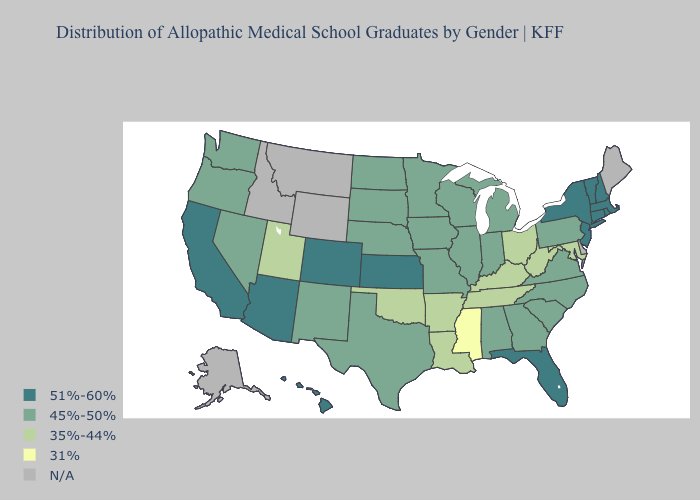Name the states that have a value in the range 51%-60%?
Short answer required. Arizona, California, Colorado, Connecticut, Florida, Hawaii, Kansas, Massachusetts, New Hampshire, New Jersey, New York, Rhode Island, Vermont. What is the highest value in the USA?
Answer briefly. 51%-60%. What is the lowest value in the USA?
Write a very short answer. 31%. Does Massachusetts have the lowest value in the USA?
Concise answer only. No. What is the highest value in the USA?
Short answer required. 51%-60%. Name the states that have a value in the range 35%-44%?
Give a very brief answer. Arkansas, Kentucky, Louisiana, Maryland, Ohio, Oklahoma, Tennessee, Utah, West Virginia. Which states have the lowest value in the South?
Keep it brief. Mississippi. Is the legend a continuous bar?
Be succinct. No. What is the highest value in the West ?
Be succinct. 51%-60%. Name the states that have a value in the range 35%-44%?
Short answer required. Arkansas, Kentucky, Louisiana, Maryland, Ohio, Oklahoma, Tennessee, Utah, West Virginia. What is the value of Hawaii?
Give a very brief answer. 51%-60%. What is the lowest value in states that border Tennessee?
Quick response, please. 31%. What is the lowest value in the MidWest?
Be succinct. 35%-44%. Which states have the lowest value in the West?
Be succinct. Utah. What is the highest value in states that border Delaware?
Short answer required. 51%-60%. 